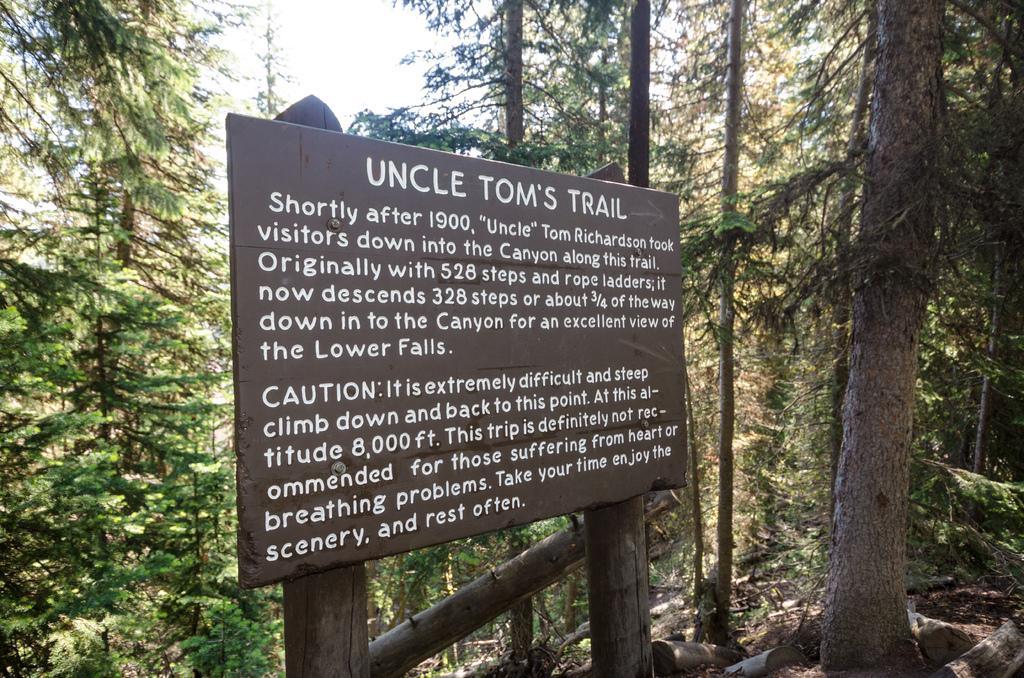Could you give a brief overview of what you see in this image? In the picture I can see a board is attached to a wooden object. On this board I can see something written on it. In the background I can see trees and the sky. 